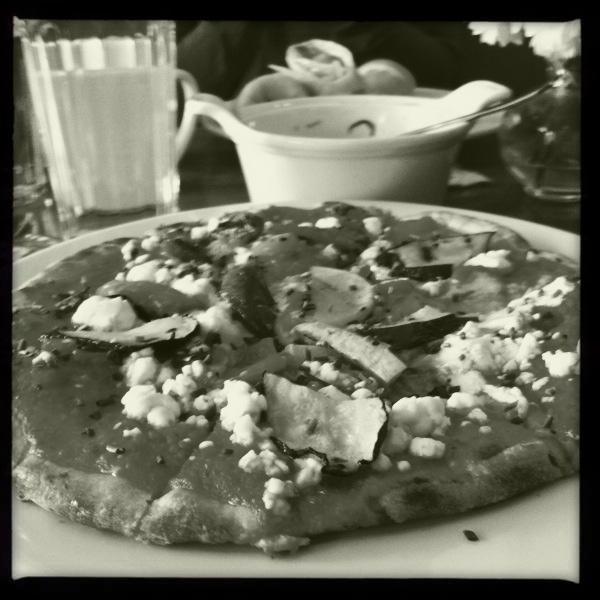How many toppings are on this pizza?
Give a very brief answer. 3. How many cups are there?
Give a very brief answer. 2. 